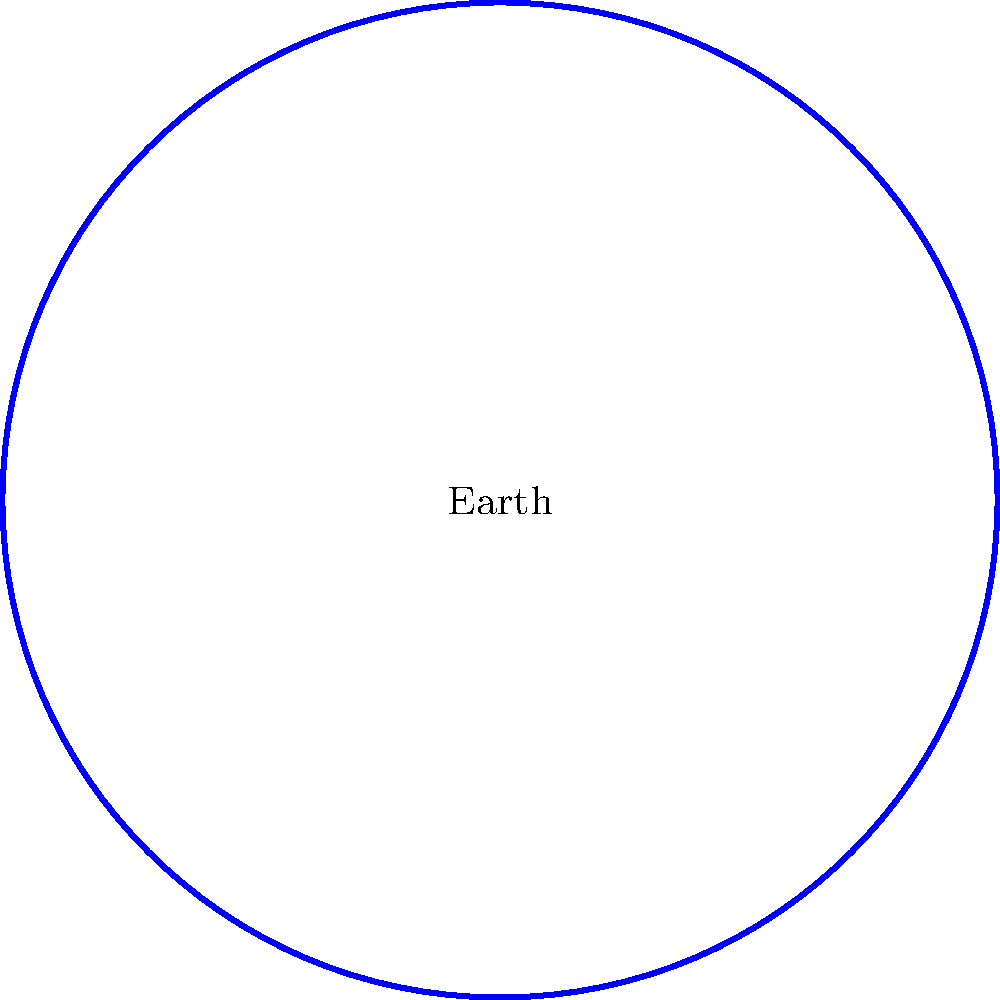In the context of representing distant galaxies alongside earthly subjects, how does the concept of angular size relate to the apparent size of objects in astrophotography, and what implications does this have for artistic composition? Use the provided diagram to illustrate your answer, considering the Earth and galaxy depicted. 1. Angular size concept:
   - Angular size is the angle subtended by an object at the point of observation.
   - It's given by the formula: $\theta \approx \frac{d}{D}$ (for small angles)
   Where $\theta$ is the angular size in radians, $d$ is the actual size of the object, and $D$ is the distance to the object.

2. Apparent size in astrophotography:
   - Despite being much larger, distant galaxies appear smaller than nearby objects due to their vast distances.
   - In the diagram, the galaxy is drawn larger than Earth for visibility, but in reality, it would appear much smaller.

3. Scale representation:
   - The dashed lines in the diagram represent perspective lines.
   - They illustrate how objects farther away (the galaxy) occupy a smaller portion of the field of view.

4. Artistic composition implications:
   - Artists must decide whether to represent objects at their true angular size or exaggerate for effect.
   - Exaggeration can be used to draw attention to distant objects that would otherwise be nearly invisible.
   - The scale provided (1 light-year) helps convey the vast distances involved.

5. Balancing realism and artistic license:
   - Artists may choose to increase the size of distant galaxies to show detail.
   - This creates tension between scientific accuracy and artistic expression.

6. Perspective manipulation:
   - By adjusting the relative sizes of Earth and the galaxy, artists can play with the viewer's sense of scale and distance.
   - This can be used to create a sense of awe or to highlight the vastness of space.

7. Composition techniques:
   - Foreground elements (like Earth) can be used to frame or contrast with background celestial objects.
   - The placement of Earth and the galaxy in the diagram suggests a diagonal composition, creating visual interest.
Answer: Angular size decreases with distance, requiring artists to balance scientific accuracy with artistic expression when depicting vastly different scales in astrophotography compositions. 